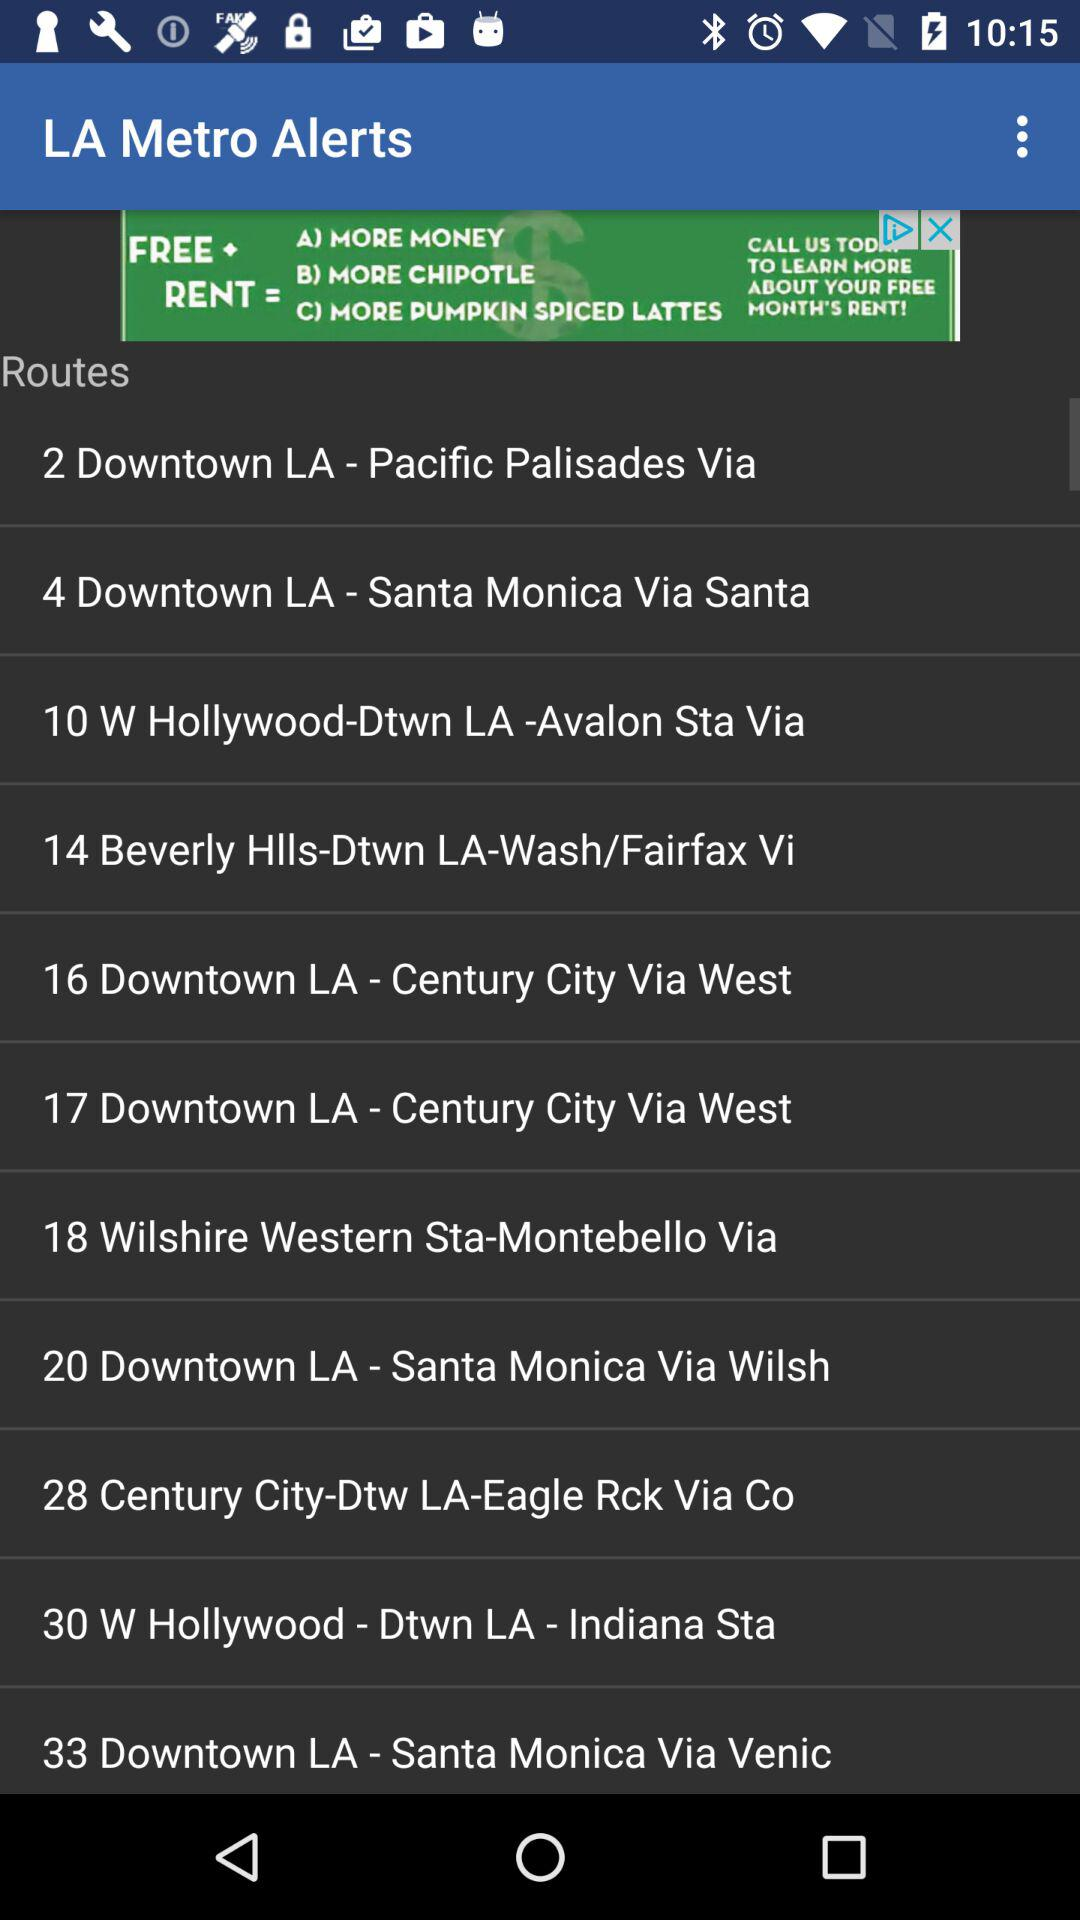What are the different routes given for "LA Metro Alerts"? The different routes given for "LA Metro Alerts" are "2 Downtown LA - Pacific Palisades Via", "4 Downtown LA - Santa Monica Via Santa", "10 W Hollywood-Dtwn LA -Avalon Sta Via", "14 Beverly Hlls-Dtwn LA-Wash/Fairfax Vi", "16 Downtown LA - Century City Via West", "17 Downtown LA - Century City Via West", "18 Wilshire Western Sta-Montebello Via", "20 Downtown LA - Santa Monica Via Wilsh", "28 Century City-Dtw LA-Eagle Rck Via Co", "30 W Hollywood - Dtwn LA - Indiana Sta" and "33 Downtown LA - Santa Monica Via Venic". 